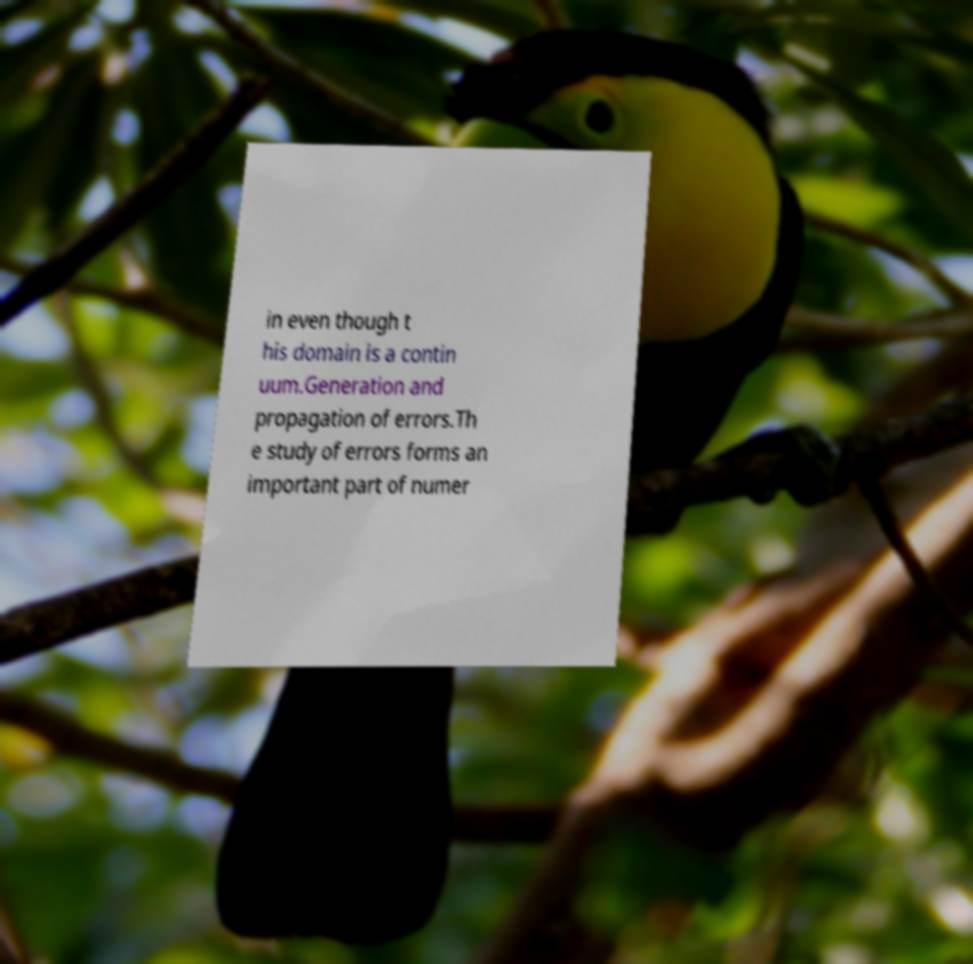There's text embedded in this image that I need extracted. Can you transcribe it verbatim? in even though t his domain is a contin uum.Generation and propagation of errors.Th e study of errors forms an important part of numer 